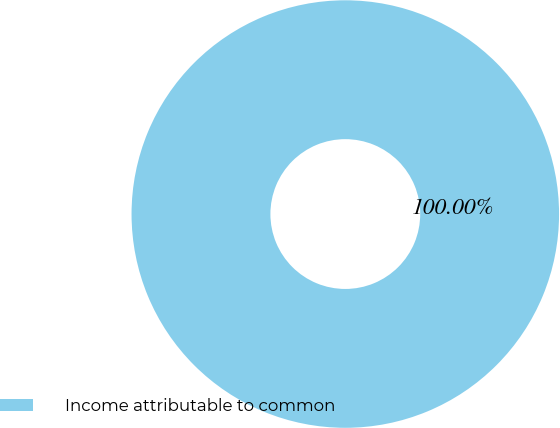<chart> <loc_0><loc_0><loc_500><loc_500><pie_chart><fcel>Income attributable to common<nl><fcel>100.0%<nl></chart> 